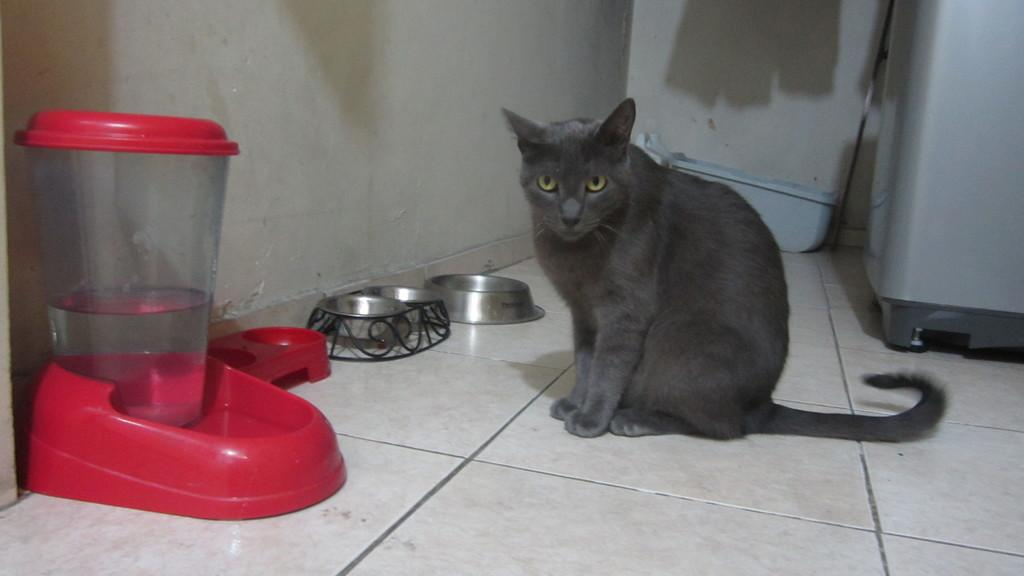What type of animal is present in the image? There is a cat in the image. What objects are present in the image that can hold food or water? There are bowls and a jar with water in the image. What type of furniture or support is present in the image? There are stands in the image. What container is present in the image? There is a container in the image. What appliance is present in the image? There is a washing machine in the image. Where are all of these objects located in the image? All of these objects are on the floor. What type of son can be seen playing with a boot in the image? There is no son or boot present in the image; it only features a cat, bowls, stands, a jar with water, a container, and a washing machine, all on the floor. 